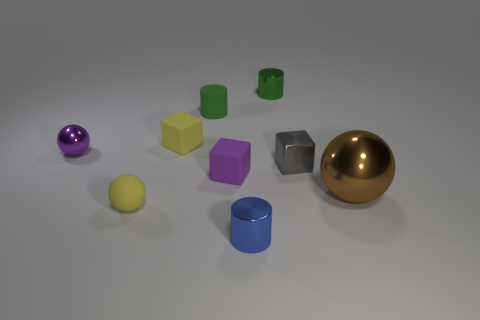Subtract 1 balls. How many balls are left? 2 Add 1 tiny blue metal cylinders. How many objects exist? 10 Subtract all balls. How many objects are left? 6 Subtract 0 cyan cylinders. How many objects are left? 9 Subtract all small green shiny things. Subtract all brown shiny spheres. How many objects are left? 7 Add 8 tiny blue objects. How many tiny blue objects are left? 9 Add 1 small shiny spheres. How many small shiny spheres exist? 2 